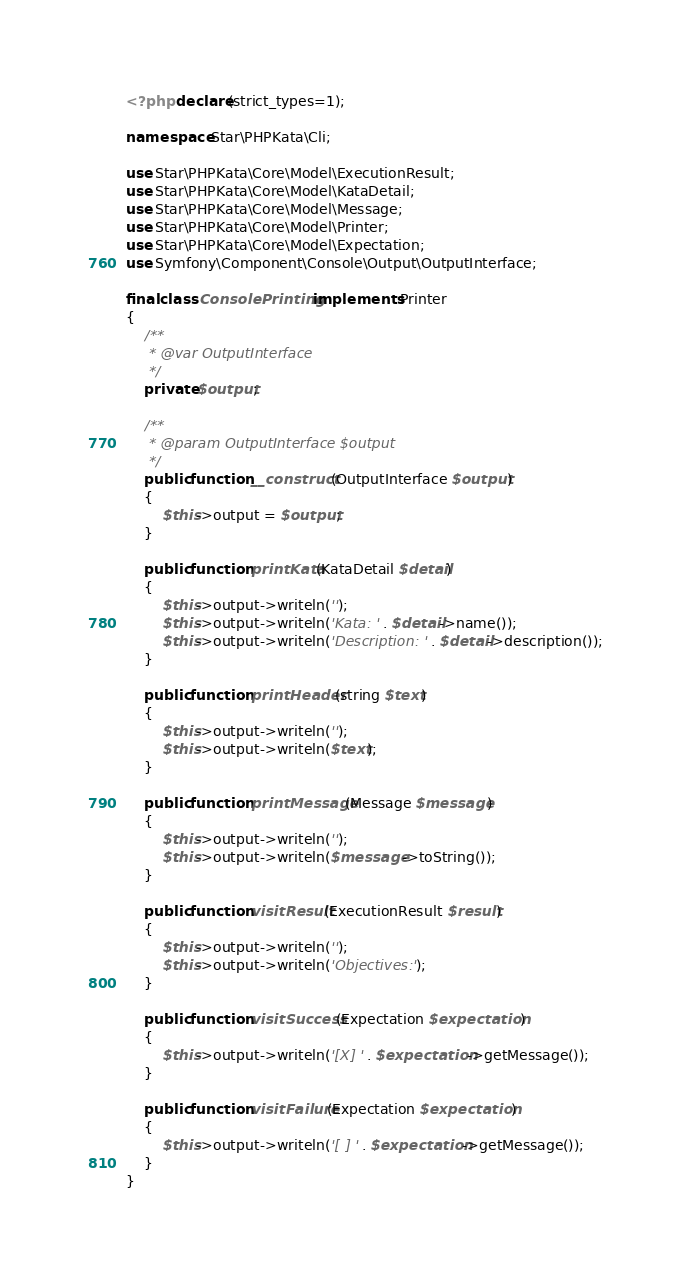Convert code to text. <code><loc_0><loc_0><loc_500><loc_500><_PHP_><?php declare(strict_types=1);

namespace Star\PHPKata\Cli;

use Star\PHPKata\Core\Model\ExecutionResult;
use Star\PHPKata\Core\Model\KataDetail;
use Star\PHPKata\Core\Model\Message;
use Star\PHPKata\Core\Model\Printer;
use Star\PHPKata\Core\Model\Expectation;
use Symfony\Component\Console\Output\OutputInterface;

final class ConsolePrinting implements Printer
{
    /**
     * @var OutputInterface
     */
    private $output;

    /**
     * @param OutputInterface $output
     */
    public function __construct(OutputInterface $output)
    {
        $this->output = $output;
    }

    public function printKata(KataDetail $detail)
    {
        $this->output->writeln('');
        $this->output->writeln('Kata: ' . $detail->name());
        $this->output->writeln('Description: ' . $detail->description());
    }

    public function printHeader(string $text)
    {
        $this->output->writeln('');
        $this->output->writeln($text);
    }

    public function printMessage(Message $message)
    {
        $this->output->writeln('');
        $this->output->writeln($message->toString());
    }

    public function visitResult(ExecutionResult $result)
    {
        $this->output->writeln('');
        $this->output->writeln('Objectives:');
    }

    public function visitSuccess(Expectation $expectation)
    {
        $this->output->writeln('[X] ' . $expectation->getMessage());
    }

    public function visitFailure(Expectation $expectation)
    {
        $this->output->writeln('[ ] ' . $expectation->getMessage());
    }
}
</code> 